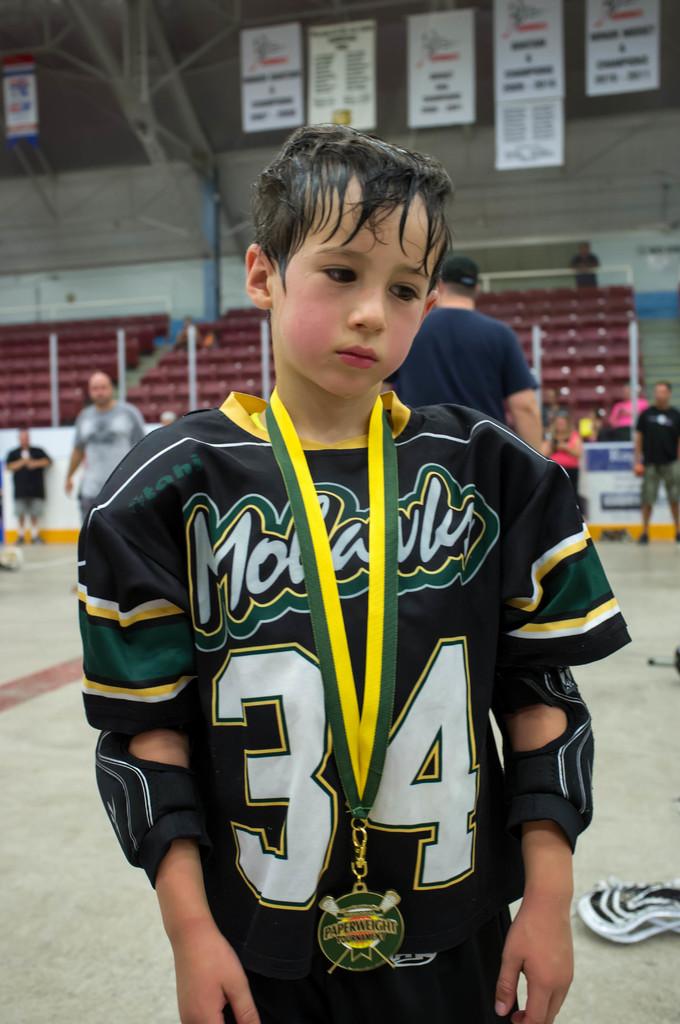What is this players number?
Make the answer very short. 34. 